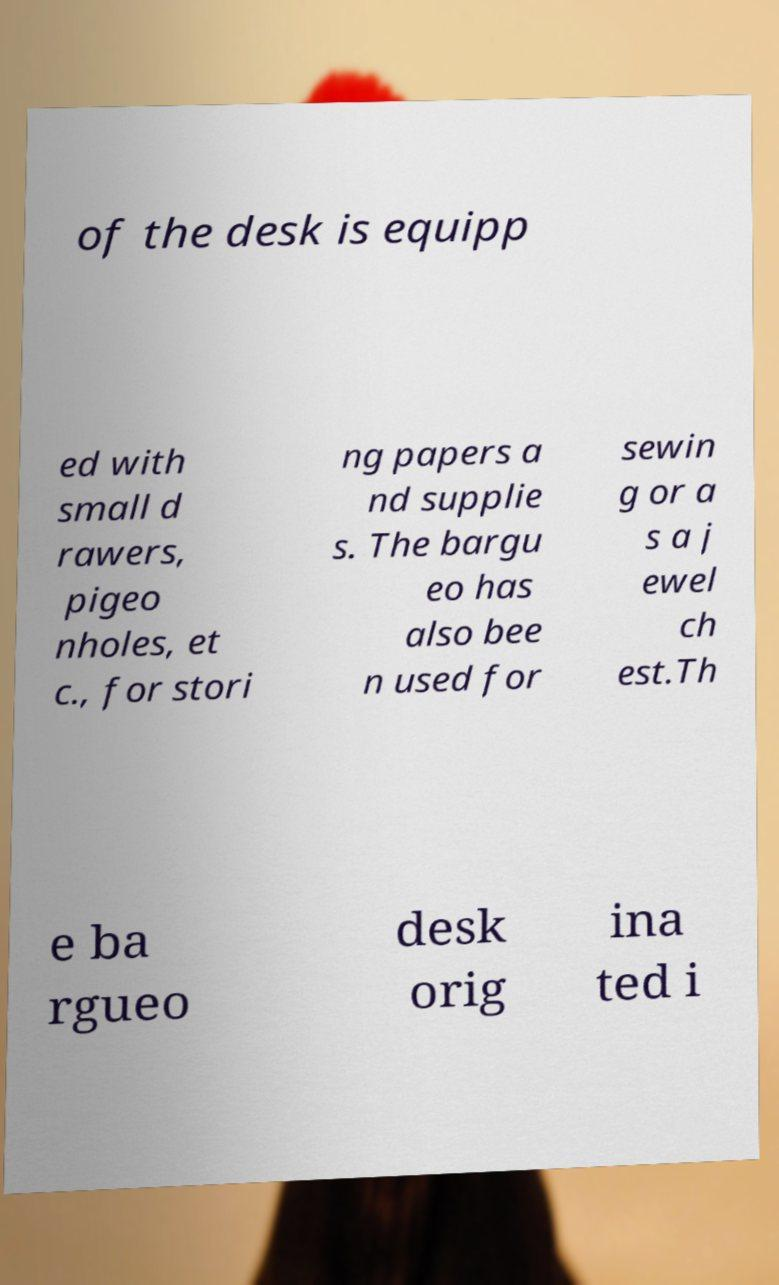Can you read and provide the text displayed in the image?This photo seems to have some interesting text. Can you extract and type it out for me? of the desk is equipp ed with small d rawers, pigeo nholes, et c., for stori ng papers a nd supplie s. The bargu eo has also bee n used for sewin g or a s a j ewel ch est.Th e ba rgueo desk orig ina ted i 